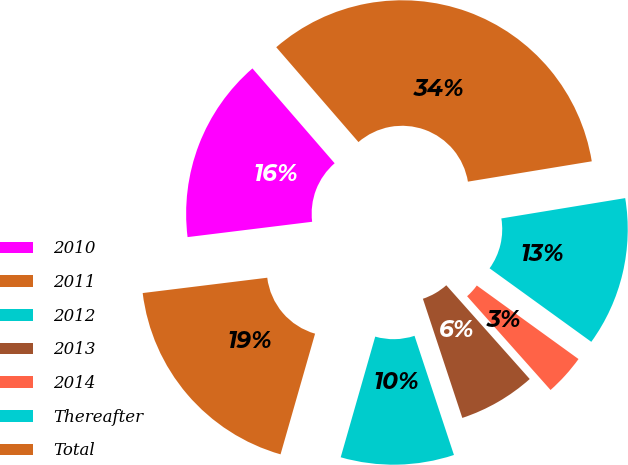Convert chart to OTSL. <chart><loc_0><loc_0><loc_500><loc_500><pie_chart><fcel>2010<fcel>2011<fcel>2012<fcel>2013<fcel>2014<fcel>Thereafter<fcel>Total<nl><fcel>15.58%<fcel>18.61%<fcel>9.52%<fcel>6.49%<fcel>3.46%<fcel>12.55%<fcel>33.77%<nl></chart> 